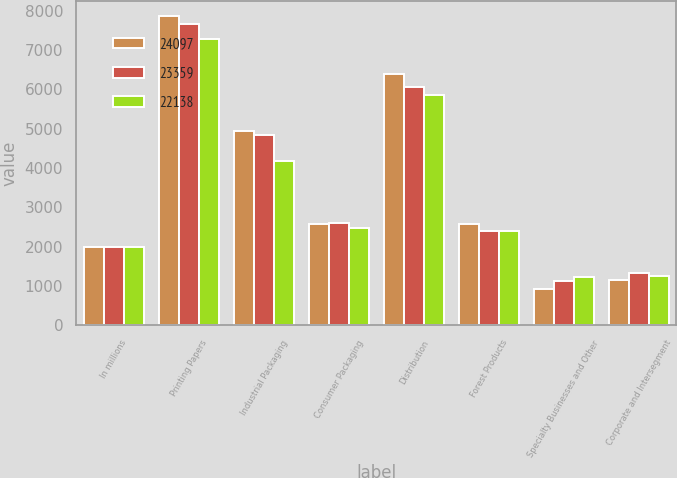Convert chart to OTSL. <chart><loc_0><loc_0><loc_500><loc_500><stacked_bar_chart><ecel><fcel>In millions<fcel>Printing Papers<fcel>Industrial Packaging<fcel>Consumer Packaging<fcel>Distribution<fcel>Forest Products<fcel>Specialty Businesses and Other<fcel>Corporate and Intersegment<nl><fcel>24097<fcel>2005<fcel>7860<fcel>4935<fcel>2590<fcel>6380<fcel>2575<fcel>915<fcel>1158<nl><fcel>23359<fcel>2004<fcel>7670<fcel>4830<fcel>2605<fcel>6065<fcel>2395<fcel>1120<fcel>1326<nl><fcel>22138<fcel>2003<fcel>7280<fcel>4170<fcel>2465<fcel>5860<fcel>2390<fcel>1235<fcel>1262<nl></chart> 